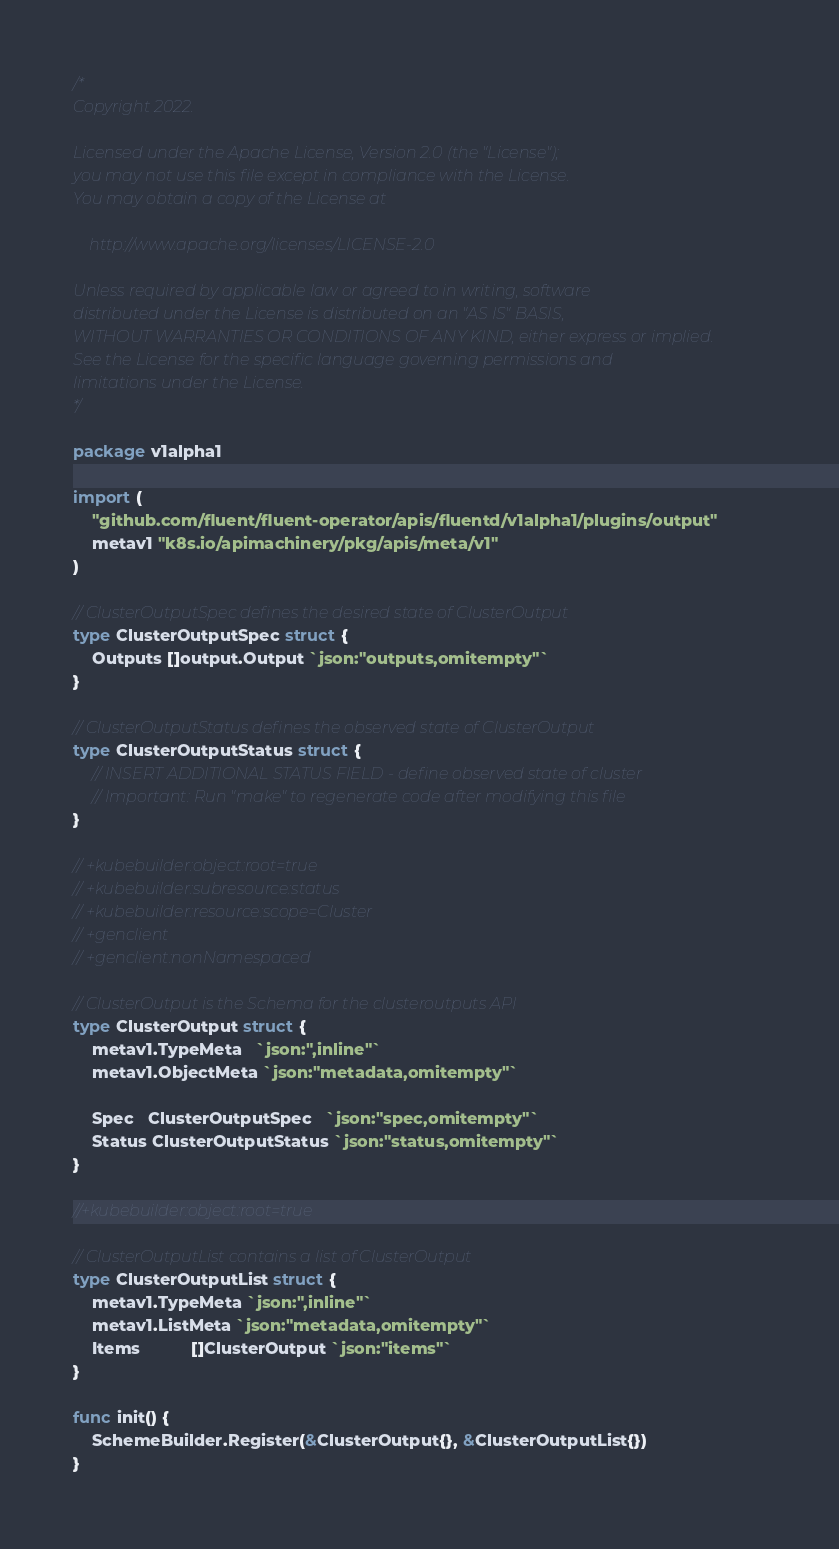<code> <loc_0><loc_0><loc_500><loc_500><_Go_>/*
Copyright 2022.

Licensed under the Apache License, Version 2.0 (the "License");
you may not use this file except in compliance with the License.
You may obtain a copy of the License at

    http://www.apache.org/licenses/LICENSE-2.0

Unless required by applicable law or agreed to in writing, software
distributed under the License is distributed on an "AS IS" BASIS,
WITHOUT WARRANTIES OR CONDITIONS OF ANY KIND, either express or implied.
See the License for the specific language governing permissions and
limitations under the License.
*/

package v1alpha1

import (
	"github.com/fluent/fluent-operator/apis/fluentd/v1alpha1/plugins/output"
	metav1 "k8s.io/apimachinery/pkg/apis/meta/v1"
)

// ClusterOutputSpec defines the desired state of ClusterOutput
type ClusterOutputSpec struct {
	Outputs []output.Output `json:"outputs,omitempty"`
}

// ClusterOutputStatus defines the observed state of ClusterOutput
type ClusterOutputStatus struct {
	// INSERT ADDITIONAL STATUS FIELD - define observed state of cluster
	// Important: Run "make" to regenerate code after modifying this file
}

// +kubebuilder:object:root=true
// +kubebuilder:subresource:status
// +kubebuilder:resource:scope=Cluster
// +genclient
// +genclient:nonNamespaced

// ClusterOutput is the Schema for the clusteroutputs API
type ClusterOutput struct {
	metav1.TypeMeta   `json:",inline"`
	metav1.ObjectMeta `json:"metadata,omitempty"`

	Spec   ClusterOutputSpec   `json:"spec,omitempty"`
	Status ClusterOutputStatus `json:"status,omitempty"`
}

//+kubebuilder:object:root=true

// ClusterOutputList contains a list of ClusterOutput
type ClusterOutputList struct {
	metav1.TypeMeta `json:",inline"`
	metav1.ListMeta `json:"metadata,omitempty"`
	Items           []ClusterOutput `json:"items"`
}

func init() {
	SchemeBuilder.Register(&ClusterOutput{}, &ClusterOutputList{})
}
</code> 